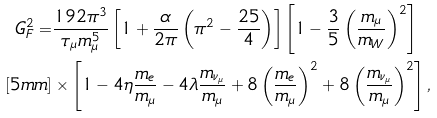<formula> <loc_0><loc_0><loc_500><loc_500>G _ { F } ^ { 2 } = & \frac { 1 9 2 \pi ^ { 3 } } { \tau _ { \mu } m ^ { 5 } _ { \mu } } \left [ 1 + \frac { \alpha } { 2 \pi } \left ( \pi ^ { 2 } - \frac { 2 5 } { 4 } \right ) \right ] \left [ 1 - \frac { 3 } { 5 } \left ( \frac { m _ { \mu } } { m _ { W } } \right ) ^ { 2 } \right ] \\ [ 5 m m ] & \times \left [ 1 - 4 \eta \frac { m _ { e } } { m _ { \mu } } - 4 \lambda \frac { m _ { \nu _ { \mu } } } { m _ { \mu } } + 8 \left ( \frac { m _ { e } } { m _ { \mu } } \right ) ^ { 2 } + 8 \left ( \frac { m _ { \nu _ { \mu } } } { m _ { \mu } } \right ) ^ { 2 } \right ] ,</formula> 